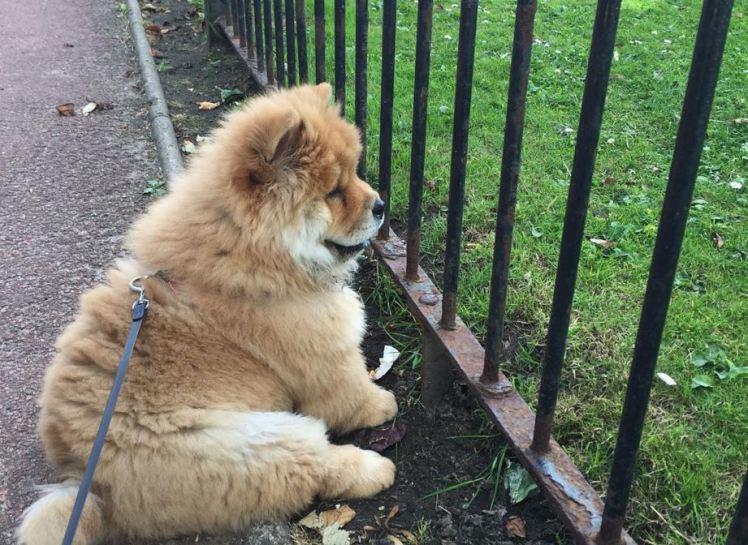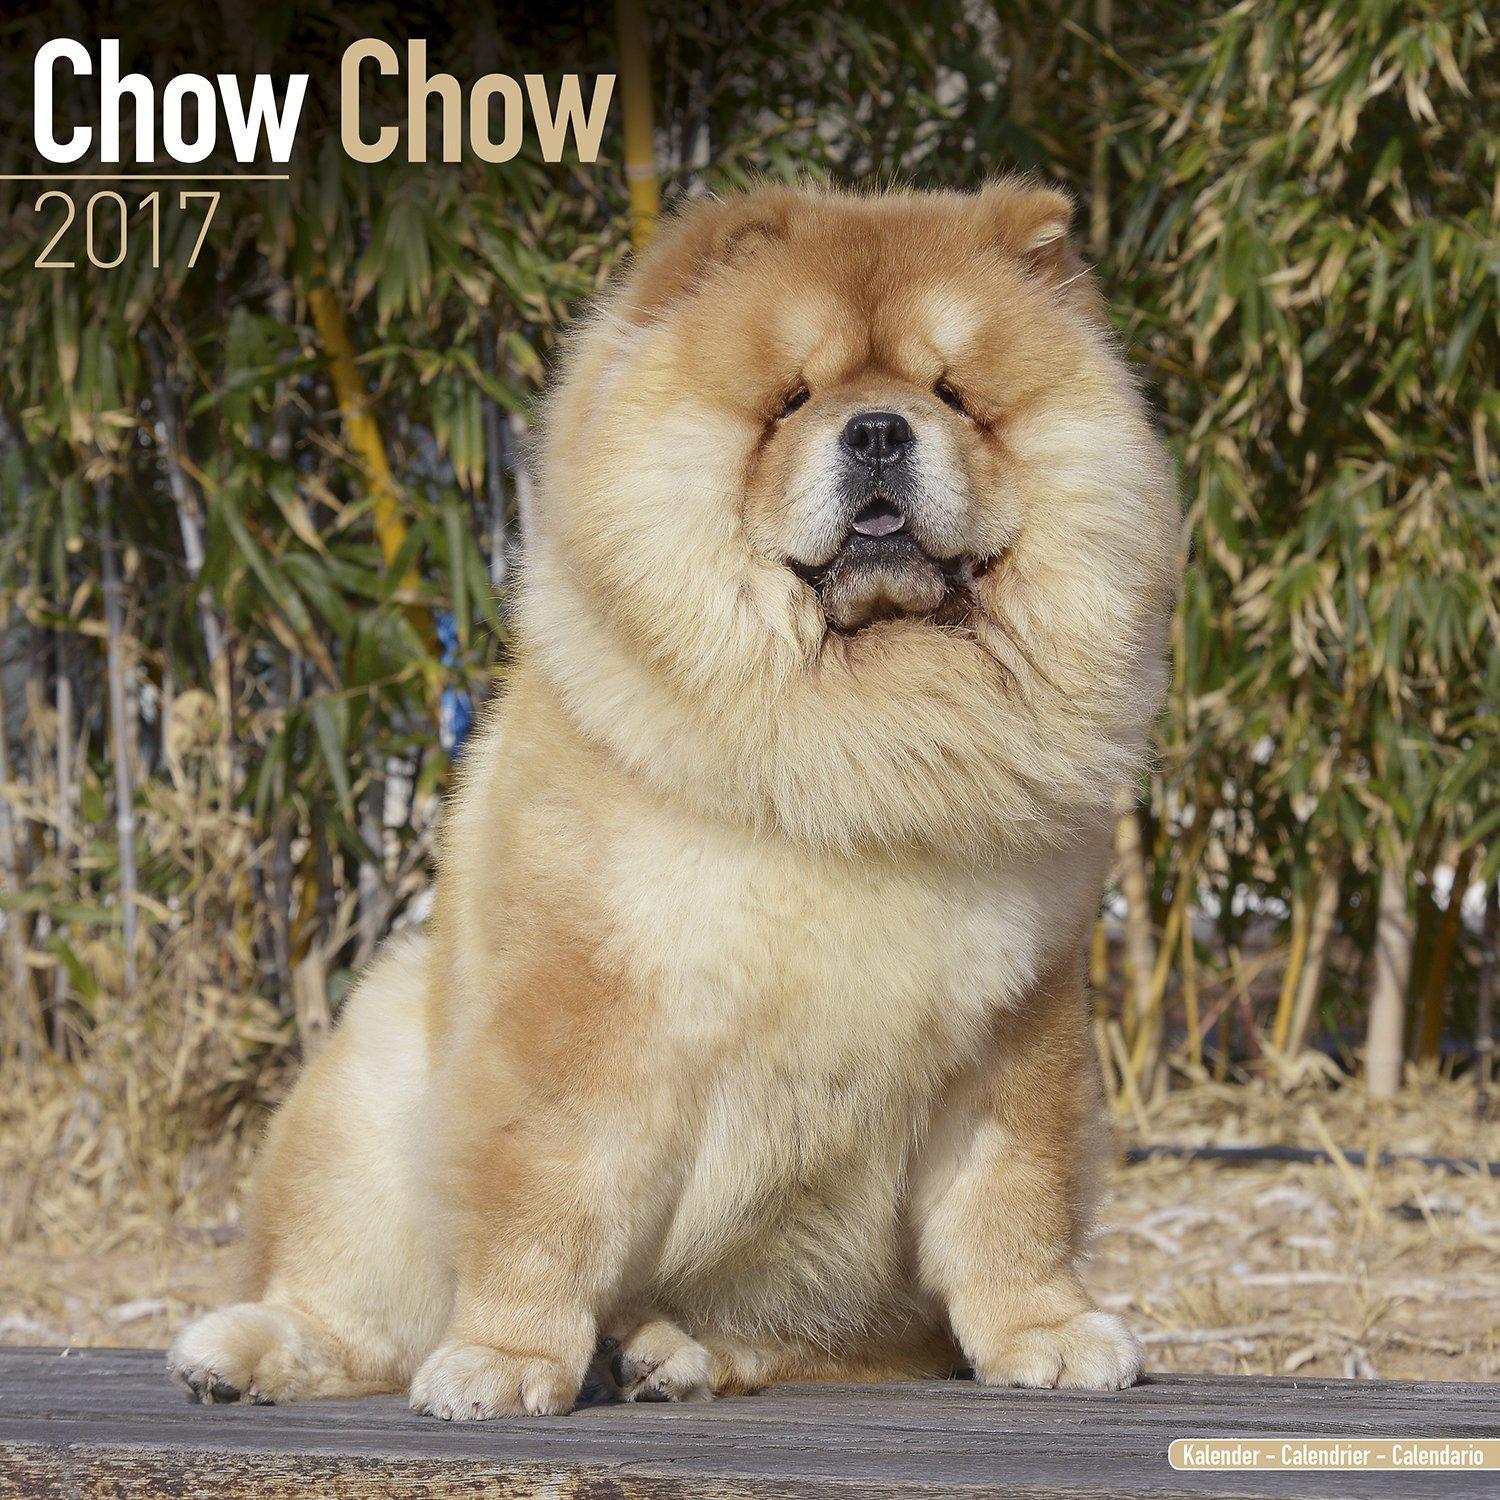The first image is the image on the left, the second image is the image on the right. Analyze the images presented: Is the assertion "The left image contains exactly one red-orange chow puppy, and the right image contains exactly one red-orange adult chow." valid? Answer yes or no. Yes. The first image is the image on the left, the second image is the image on the right. Evaluate the accuracy of this statement regarding the images: "There are just two dogs.". Is it true? Answer yes or no. Yes. 